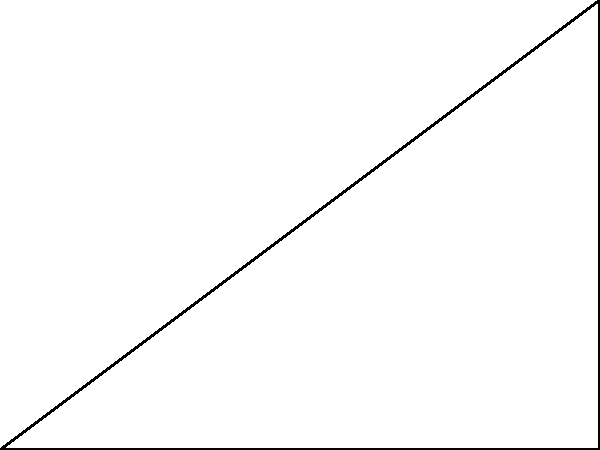In the iconic lighting setup for film noir, the key light is often positioned at a high angle to create dramatic shadows. Consider the diagram where O represents the camera, A the subject, and B the light source. If OA = 4 units and AB = 3 units, what is the optimal angle θ (in degrees) between the camera-subject line and the subject-light line to achieve the characteristic film noir look? To determine the optimal angle θ for the film noir lighting setup, we'll follow these steps:

1) First, we need to recognize that we're dealing with a right-angled triangle OAB, where OA is the base and AB is the height.

2) The angle θ we're looking for is the angle between OA and BA.

3) We can calculate this angle using the arctangent function:

   $\theta = \arctan(\frac{\text{opposite}}{\text{adjacent}})$

4) In this case:
   - The opposite side is AB = 3 units
   - The adjacent side is OA = 4 units

5) Plugging these values into our formula:

   $\theta = \arctan(\frac{3}{4})$

6) Using a calculator or mathematical software:

   $\theta \approx 36.87°$

7) For the characteristic film noir look, this angle is typically rounded to 37°.

This high angle creates long, dramatic shadows that are emblematic of the film noir style, enhancing the mood and atmosphere of the scene.
Answer: 37° 